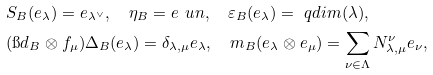Convert formula to latex. <formula><loc_0><loc_0><loc_500><loc_500>& S _ { B } ( e _ { \lambda } ) = e _ { \lambda ^ { \vee } } , \quad \eta _ { B } = e _ { \ } u n , \quad \varepsilon _ { B } ( e _ { \lambda } ) = \ q d i m ( \lambda ) , \\ & ( \i d _ { B } \otimes f _ { \mu } ) \Delta _ { B } ( e _ { \lambda } ) = \delta _ { \lambda , \mu } e _ { \lambda } , \quad m _ { B } ( e _ { \lambda } \otimes e _ { \mu } ) = \sum _ { \nu \in \Lambda } N _ { \lambda , \mu } ^ { \nu } e _ { \nu } ,</formula> 